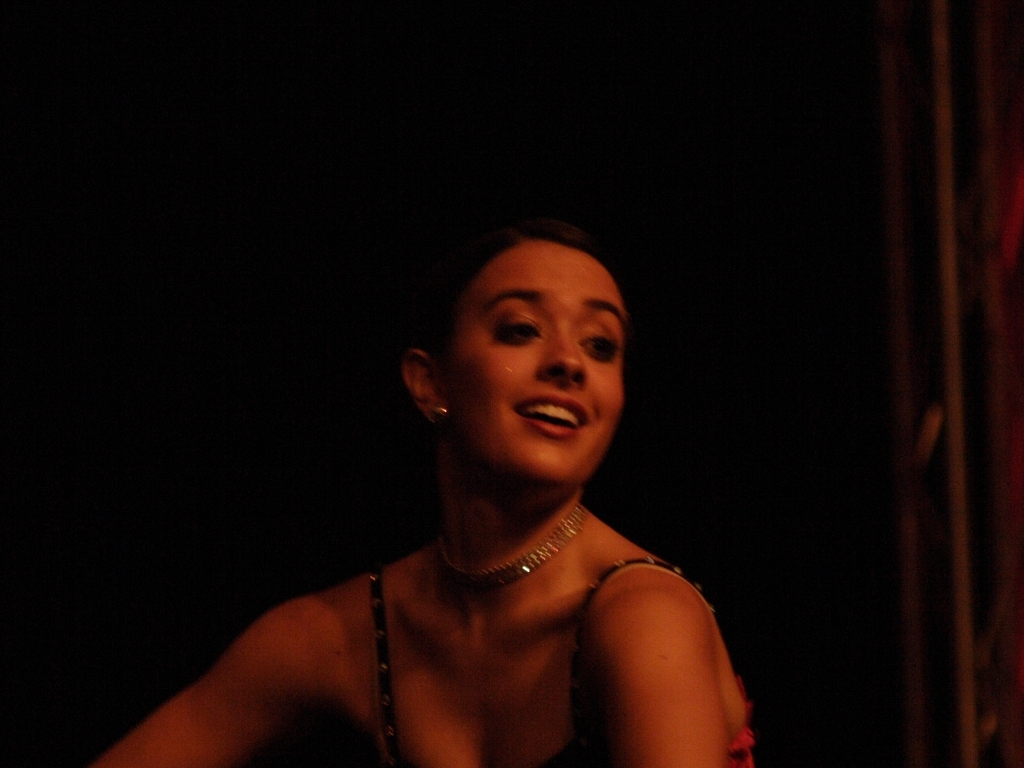How clear are the facial expressions of the subjects in this image? A. completely blurry B. relatively clear C. indiscernible Option B is the most accurate. While the subject's facial expressions are not perfectly sharp due to the image's lighting and motion, they are moderately discernable, conveying a sense of emotion and expression. 